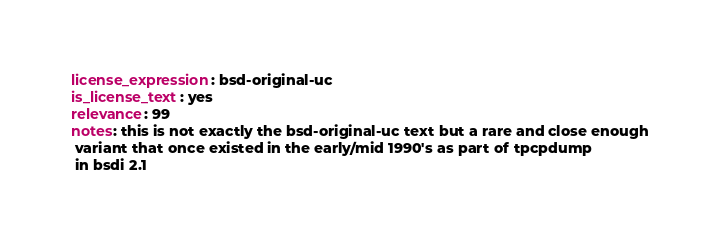Convert code to text. <code><loc_0><loc_0><loc_500><loc_500><_YAML_>license_expression: bsd-original-uc
is_license_text: yes
relevance: 99
notes: this is not exactly the bsd-original-uc text but a rare and close enough
 variant that once existed in the early/mid 1990's as part of tpcpdump
 in bsdi 2.1</code> 